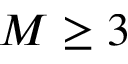Convert formula to latex. <formula><loc_0><loc_0><loc_500><loc_500>M \geq 3</formula> 